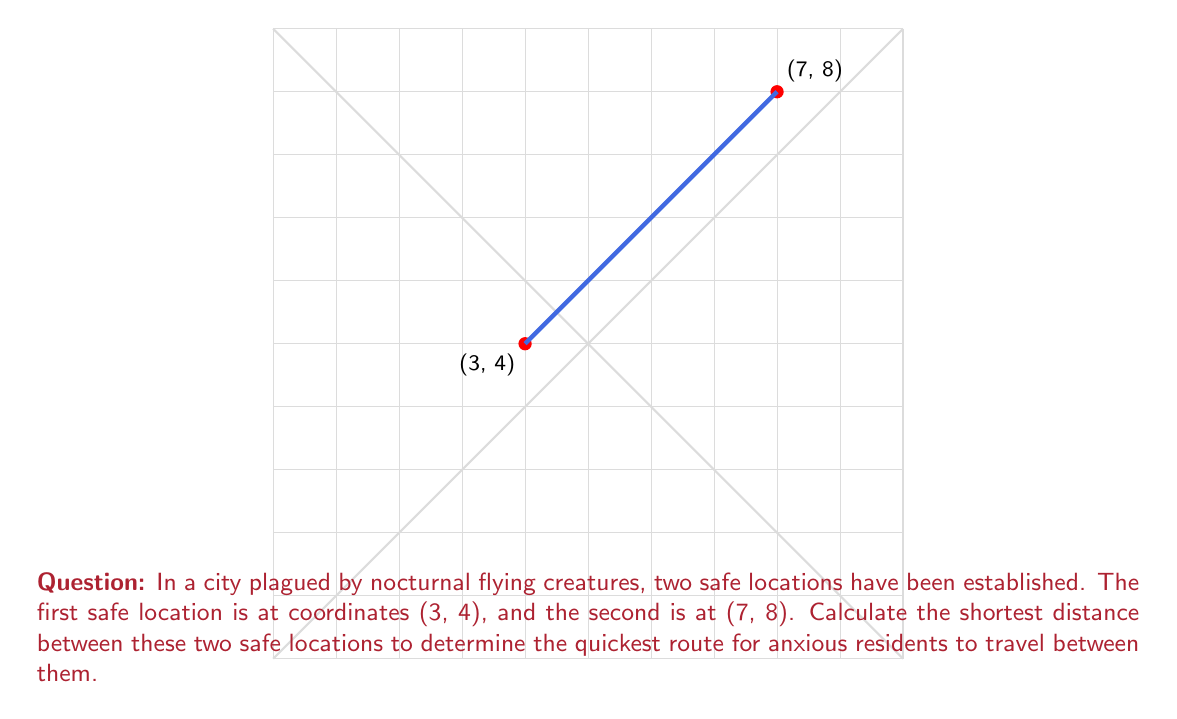Provide a solution to this math problem. To find the shortest distance between two points on a coordinate plane, we use the distance formula, which is derived from the Pythagorean theorem:

$$ d = \sqrt{(x_2 - x_1)^2 + (y_2 - y_1)^2} $$

Where $(x_1, y_1)$ is the first point and $(x_2, y_2)$ is the second point.

Given:
- First safe location: $(x_1, y_1) = (3, 4)$
- Second safe location: $(x_2, y_2) = (7, 8)$

Let's substitute these values into the formula:

$$ d = \sqrt{(7 - 3)^2 + (8 - 4)^2} $$

Now, let's solve step-by-step:

1) Simplify the expressions inside the parentheses:
   $$ d = \sqrt{4^2 + 4^2} $$

2) Calculate the squares:
   $$ d = \sqrt{16 + 16} $$

3) Add the values under the square root:
   $$ d = \sqrt{32} $$

4) Simplify the square root:
   $$ d = 4\sqrt{2} $$

This is the exact value of the distance. If a decimal approximation is needed, we can calculate:

$$ d \approx 4 \times 1.4142 \approx 5.6568 $$

Therefore, the shortest distance between the two safe locations is $4\sqrt{2}$ units, or approximately 5.6568 units.
Answer: $4\sqrt{2}$ units 